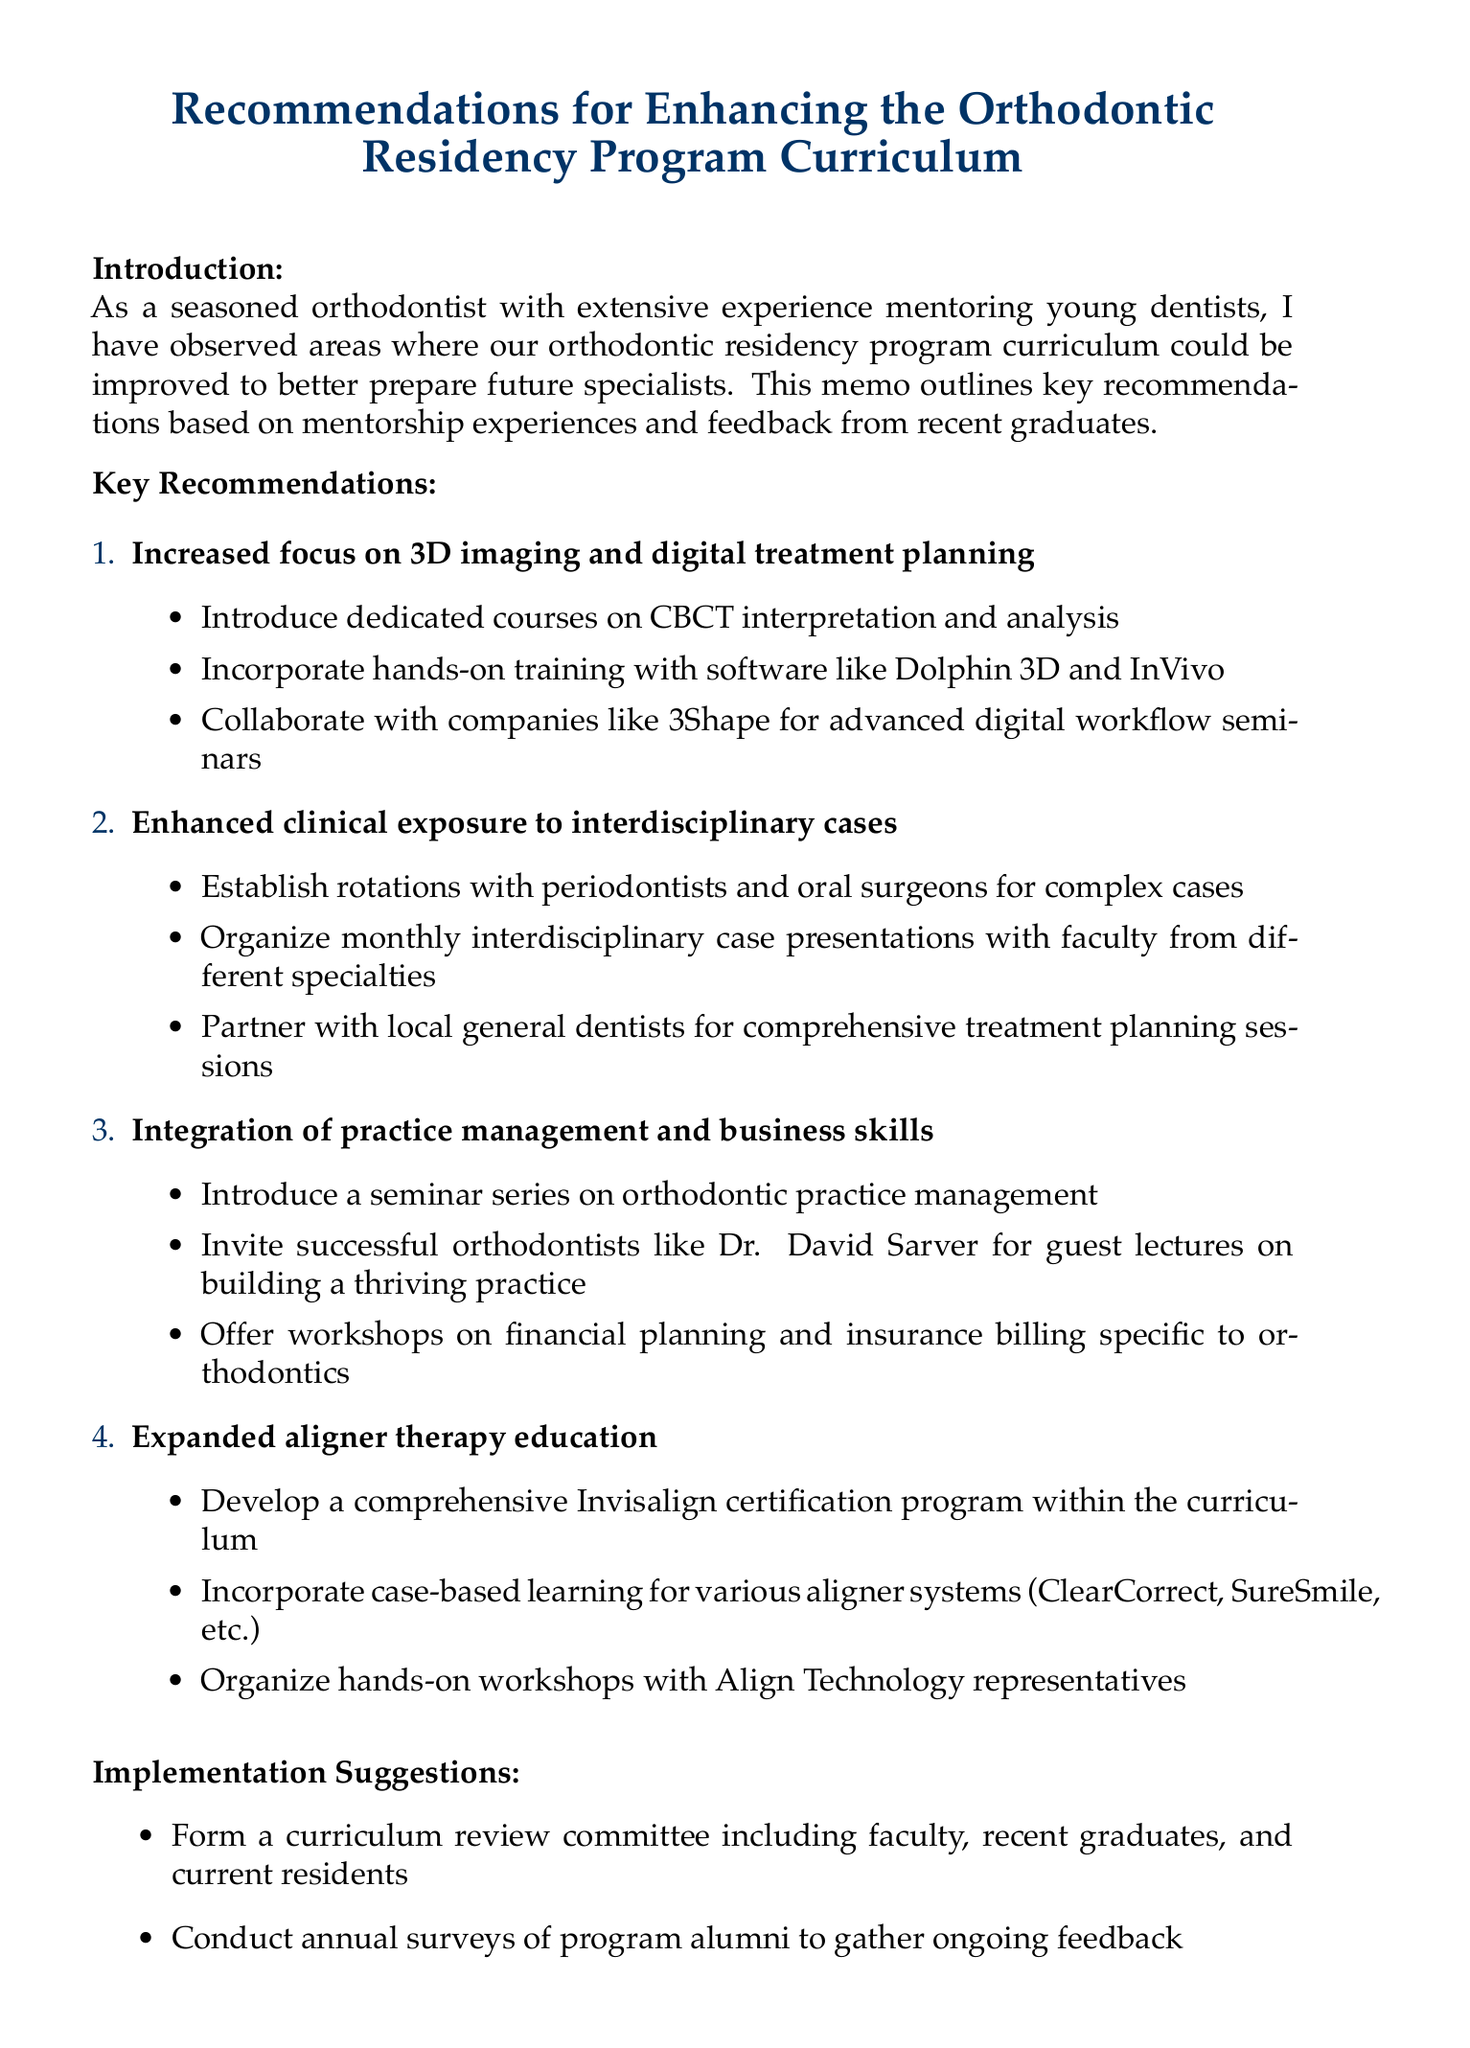What is the title of the memo? The title is provided at the beginning of the document.
Answer: Recommendations for Enhancing the Orthodontic Residency Program Curriculum Who is the author of the memo? The author identifies themselves in the introduction section.
Answer: A seasoned orthodontist What is one of the main topics covered in the recommendations? The document lists specific topics in the key recommendations section.
Answer: Increased focus on 3D imaging and digital treatment planning What is a suggested implementation action? Implementation suggestions are provided towards the end of the document.
Answer: Form a curriculum review committee Who did the author suggest to invite for guest lectures? The author mentions specific individuals in the recommendations for practice management.
Answer: Dr. David Sarver How many main recommendation topics are listed in the document? The number of topics is indicated in the key recommendations section.
Answer: Four What type of education is emphasized in the section on aligner therapy? The details in that section point towards specific educational offerings.
Answer: Comprehensive Invisalign certification program What is a suggested resource for continued education? Additional resources are provided at the end of the memo.
Answer: American Association of Orthodontists (AAO) Education Resources What is the purpose of the memo? The purpose can be inferred from the introduction.
Answer: To outline key recommendations based on mentorship experiences and feedback from recent graduates 